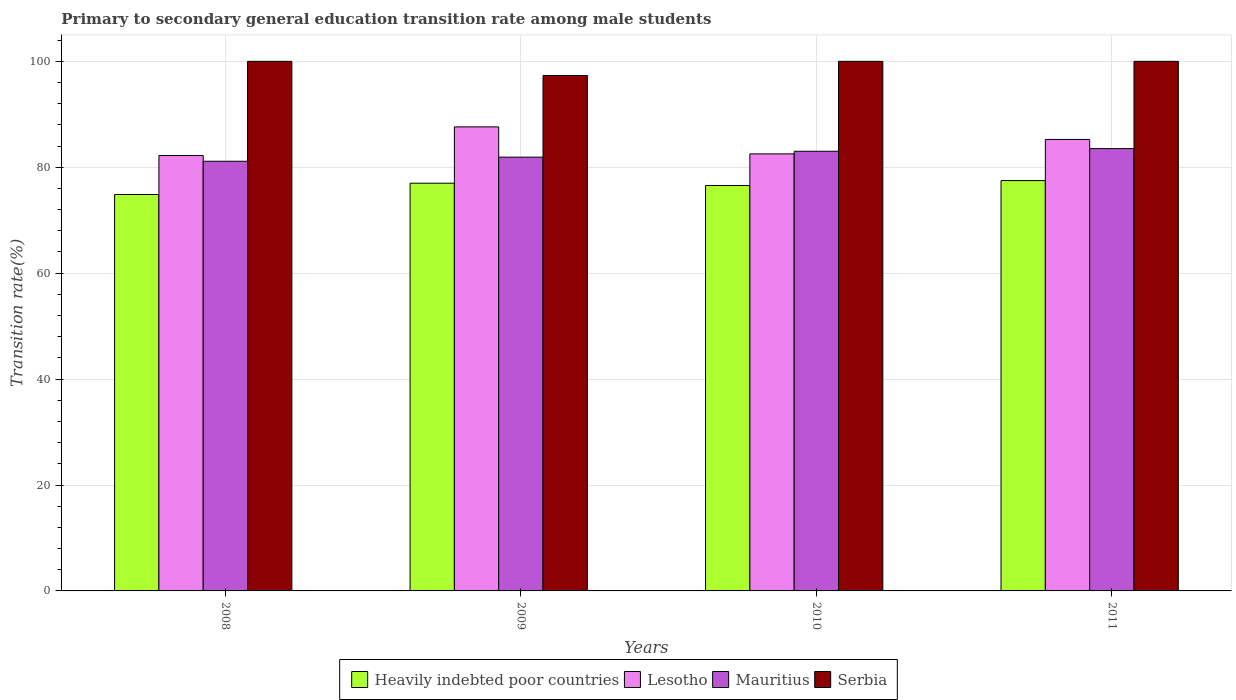How many groups of bars are there?
Offer a very short reply. 4. Are the number of bars per tick equal to the number of legend labels?
Make the answer very short. Yes. Are the number of bars on each tick of the X-axis equal?
Offer a very short reply. Yes. How many bars are there on the 1st tick from the left?
Your answer should be very brief. 4. How many bars are there on the 1st tick from the right?
Provide a short and direct response. 4. What is the label of the 4th group of bars from the left?
Your answer should be very brief. 2011. What is the transition rate in Heavily indebted poor countries in 2010?
Offer a very short reply. 76.56. Across all years, what is the minimum transition rate in Heavily indebted poor countries?
Provide a succinct answer. 74.86. In which year was the transition rate in Mauritius maximum?
Make the answer very short. 2011. In which year was the transition rate in Lesotho minimum?
Offer a terse response. 2008. What is the total transition rate in Serbia in the graph?
Provide a succinct answer. 397.33. What is the difference between the transition rate in Serbia in 2009 and that in 2011?
Offer a terse response. -2.67. What is the difference between the transition rate in Serbia in 2011 and the transition rate in Mauritius in 2010?
Provide a short and direct response. 16.98. What is the average transition rate in Heavily indebted poor countries per year?
Provide a succinct answer. 76.47. In the year 2010, what is the difference between the transition rate in Heavily indebted poor countries and transition rate in Lesotho?
Give a very brief answer. -5.97. What is the ratio of the transition rate in Heavily indebted poor countries in 2009 to that in 2011?
Make the answer very short. 0.99. What is the difference between the highest and the second highest transition rate in Heavily indebted poor countries?
Give a very brief answer. 0.49. What is the difference between the highest and the lowest transition rate in Serbia?
Make the answer very short. 2.67. In how many years, is the transition rate in Mauritius greater than the average transition rate in Mauritius taken over all years?
Your response must be concise. 2. Is the sum of the transition rate in Serbia in 2009 and 2011 greater than the maximum transition rate in Heavily indebted poor countries across all years?
Provide a short and direct response. Yes. What does the 2nd bar from the left in 2010 represents?
Your answer should be very brief. Lesotho. What does the 1st bar from the right in 2010 represents?
Give a very brief answer. Serbia. Is it the case that in every year, the sum of the transition rate in Lesotho and transition rate in Serbia is greater than the transition rate in Heavily indebted poor countries?
Make the answer very short. Yes. Are all the bars in the graph horizontal?
Provide a succinct answer. No. How many years are there in the graph?
Provide a short and direct response. 4. What is the difference between two consecutive major ticks on the Y-axis?
Your response must be concise. 20. Are the values on the major ticks of Y-axis written in scientific E-notation?
Keep it short and to the point. No. Where does the legend appear in the graph?
Give a very brief answer. Bottom center. How are the legend labels stacked?
Give a very brief answer. Horizontal. What is the title of the graph?
Your answer should be compact. Primary to secondary general education transition rate among male students. What is the label or title of the Y-axis?
Keep it short and to the point. Transition rate(%). What is the Transition rate(%) in Heavily indebted poor countries in 2008?
Your answer should be very brief. 74.86. What is the Transition rate(%) in Lesotho in 2008?
Your answer should be very brief. 82.22. What is the Transition rate(%) in Mauritius in 2008?
Provide a short and direct response. 81.13. What is the Transition rate(%) of Serbia in 2008?
Give a very brief answer. 100. What is the Transition rate(%) of Heavily indebted poor countries in 2009?
Ensure brevity in your answer.  76.99. What is the Transition rate(%) in Lesotho in 2009?
Your answer should be very brief. 87.62. What is the Transition rate(%) of Mauritius in 2009?
Your response must be concise. 81.91. What is the Transition rate(%) in Serbia in 2009?
Your answer should be very brief. 97.33. What is the Transition rate(%) of Heavily indebted poor countries in 2010?
Provide a succinct answer. 76.56. What is the Transition rate(%) in Lesotho in 2010?
Offer a very short reply. 82.53. What is the Transition rate(%) of Mauritius in 2010?
Offer a very short reply. 83.02. What is the Transition rate(%) of Heavily indebted poor countries in 2011?
Provide a short and direct response. 77.48. What is the Transition rate(%) of Lesotho in 2011?
Offer a very short reply. 85.25. What is the Transition rate(%) of Mauritius in 2011?
Your answer should be very brief. 83.52. Across all years, what is the maximum Transition rate(%) in Heavily indebted poor countries?
Your answer should be compact. 77.48. Across all years, what is the maximum Transition rate(%) of Lesotho?
Provide a short and direct response. 87.62. Across all years, what is the maximum Transition rate(%) of Mauritius?
Provide a short and direct response. 83.52. Across all years, what is the minimum Transition rate(%) of Heavily indebted poor countries?
Provide a succinct answer. 74.86. Across all years, what is the minimum Transition rate(%) in Lesotho?
Offer a terse response. 82.22. Across all years, what is the minimum Transition rate(%) in Mauritius?
Ensure brevity in your answer.  81.13. Across all years, what is the minimum Transition rate(%) of Serbia?
Your answer should be very brief. 97.33. What is the total Transition rate(%) of Heavily indebted poor countries in the graph?
Offer a terse response. 305.89. What is the total Transition rate(%) of Lesotho in the graph?
Offer a very short reply. 337.62. What is the total Transition rate(%) in Mauritius in the graph?
Provide a short and direct response. 329.59. What is the total Transition rate(%) in Serbia in the graph?
Offer a very short reply. 397.33. What is the difference between the Transition rate(%) in Heavily indebted poor countries in 2008 and that in 2009?
Ensure brevity in your answer.  -2.13. What is the difference between the Transition rate(%) in Lesotho in 2008 and that in 2009?
Provide a succinct answer. -5.41. What is the difference between the Transition rate(%) in Mauritius in 2008 and that in 2009?
Provide a short and direct response. -0.78. What is the difference between the Transition rate(%) in Serbia in 2008 and that in 2009?
Your answer should be very brief. 2.67. What is the difference between the Transition rate(%) in Heavily indebted poor countries in 2008 and that in 2010?
Offer a terse response. -1.7. What is the difference between the Transition rate(%) in Lesotho in 2008 and that in 2010?
Give a very brief answer. -0.31. What is the difference between the Transition rate(%) in Mauritius in 2008 and that in 2010?
Give a very brief answer. -1.88. What is the difference between the Transition rate(%) of Serbia in 2008 and that in 2010?
Provide a succinct answer. 0. What is the difference between the Transition rate(%) in Heavily indebted poor countries in 2008 and that in 2011?
Give a very brief answer. -2.63. What is the difference between the Transition rate(%) of Lesotho in 2008 and that in 2011?
Your answer should be compact. -3.04. What is the difference between the Transition rate(%) of Mauritius in 2008 and that in 2011?
Offer a terse response. -2.39. What is the difference between the Transition rate(%) of Heavily indebted poor countries in 2009 and that in 2010?
Your response must be concise. 0.43. What is the difference between the Transition rate(%) of Lesotho in 2009 and that in 2010?
Your answer should be very brief. 5.1. What is the difference between the Transition rate(%) of Mauritius in 2009 and that in 2010?
Ensure brevity in your answer.  -1.11. What is the difference between the Transition rate(%) of Serbia in 2009 and that in 2010?
Ensure brevity in your answer.  -2.67. What is the difference between the Transition rate(%) in Heavily indebted poor countries in 2009 and that in 2011?
Keep it short and to the point. -0.49. What is the difference between the Transition rate(%) of Lesotho in 2009 and that in 2011?
Your response must be concise. 2.37. What is the difference between the Transition rate(%) in Mauritius in 2009 and that in 2011?
Offer a very short reply. -1.61. What is the difference between the Transition rate(%) in Serbia in 2009 and that in 2011?
Provide a short and direct response. -2.67. What is the difference between the Transition rate(%) in Heavily indebted poor countries in 2010 and that in 2011?
Provide a succinct answer. -0.93. What is the difference between the Transition rate(%) in Lesotho in 2010 and that in 2011?
Provide a succinct answer. -2.73. What is the difference between the Transition rate(%) in Mauritius in 2010 and that in 2011?
Give a very brief answer. -0.51. What is the difference between the Transition rate(%) of Serbia in 2010 and that in 2011?
Provide a short and direct response. 0. What is the difference between the Transition rate(%) in Heavily indebted poor countries in 2008 and the Transition rate(%) in Lesotho in 2009?
Give a very brief answer. -12.77. What is the difference between the Transition rate(%) in Heavily indebted poor countries in 2008 and the Transition rate(%) in Mauritius in 2009?
Offer a very short reply. -7.05. What is the difference between the Transition rate(%) of Heavily indebted poor countries in 2008 and the Transition rate(%) of Serbia in 2009?
Your response must be concise. -22.48. What is the difference between the Transition rate(%) of Lesotho in 2008 and the Transition rate(%) of Mauritius in 2009?
Keep it short and to the point. 0.31. What is the difference between the Transition rate(%) of Lesotho in 2008 and the Transition rate(%) of Serbia in 2009?
Make the answer very short. -15.12. What is the difference between the Transition rate(%) in Mauritius in 2008 and the Transition rate(%) in Serbia in 2009?
Provide a short and direct response. -16.2. What is the difference between the Transition rate(%) of Heavily indebted poor countries in 2008 and the Transition rate(%) of Lesotho in 2010?
Offer a terse response. -7.67. What is the difference between the Transition rate(%) of Heavily indebted poor countries in 2008 and the Transition rate(%) of Mauritius in 2010?
Provide a short and direct response. -8.16. What is the difference between the Transition rate(%) of Heavily indebted poor countries in 2008 and the Transition rate(%) of Serbia in 2010?
Provide a succinct answer. -25.14. What is the difference between the Transition rate(%) of Lesotho in 2008 and the Transition rate(%) of Mauritius in 2010?
Provide a short and direct response. -0.8. What is the difference between the Transition rate(%) in Lesotho in 2008 and the Transition rate(%) in Serbia in 2010?
Keep it short and to the point. -17.78. What is the difference between the Transition rate(%) of Mauritius in 2008 and the Transition rate(%) of Serbia in 2010?
Offer a terse response. -18.87. What is the difference between the Transition rate(%) in Heavily indebted poor countries in 2008 and the Transition rate(%) in Lesotho in 2011?
Provide a short and direct response. -10.4. What is the difference between the Transition rate(%) of Heavily indebted poor countries in 2008 and the Transition rate(%) of Mauritius in 2011?
Your answer should be compact. -8.67. What is the difference between the Transition rate(%) in Heavily indebted poor countries in 2008 and the Transition rate(%) in Serbia in 2011?
Ensure brevity in your answer.  -25.14. What is the difference between the Transition rate(%) of Lesotho in 2008 and the Transition rate(%) of Mauritius in 2011?
Offer a terse response. -1.31. What is the difference between the Transition rate(%) in Lesotho in 2008 and the Transition rate(%) in Serbia in 2011?
Give a very brief answer. -17.78. What is the difference between the Transition rate(%) in Mauritius in 2008 and the Transition rate(%) in Serbia in 2011?
Your answer should be compact. -18.87. What is the difference between the Transition rate(%) of Heavily indebted poor countries in 2009 and the Transition rate(%) of Lesotho in 2010?
Ensure brevity in your answer.  -5.54. What is the difference between the Transition rate(%) of Heavily indebted poor countries in 2009 and the Transition rate(%) of Mauritius in 2010?
Provide a short and direct response. -6.03. What is the difference between the Transition rate(%) in Heavily indebted poor countries in 2009 and the Transition rate(%) in Serbia in 2010?
Offer a very short reply. -23.01. What is the difference between the Transition rate(%) of Lesotho in 2009 and the Transition rate(%) of Mauritius in 2010?
Provide a short and direct response. 4.6. What is the difference between the Transition rate(%) of Lesotho in 2009 and the Transition rate(%) of Serbia in 2010?
Offer a very short reply. -12.38. What is the difference between the Transition rate(%) in Mauritius in 2009 and the Transition rate(%) in Serbia in 2010?
Offer a terse response. -18.09. What is the difference between the Transition rate(%) of Heavily indebted poor countries in 2009 and the Transition rate(%) of Lesotho in 2011?
Make the answer very short. -8.26. What is the difference between the Transition rate(%) in Heavily indebted poor countries in 2009 and the Transition rate(%) in Mauritius in 2011?
Your response must be concise. -6.53. What is the difference between the Transition rate(%) of Heavily indebted poor countries in 2009 and the Transition rate(%) of Serbia in 2011?
Keep it short and to the point. -23.01. What is the difference between the Transition rate(%) of Lesotho in 2009 and the Transition rate(%) of Mauritius in 2011?
Keep it short and to the point. 4.1. What is the difference between the Transition rate(%) of Lesotho in 2009 and the Transition rate(%) of Serbia in 2011?
Provide a succinct answer. -12.38. What is the difference between the Transition rate(%) in Mauritius in 2009 and the Transition rate(%) in Serbia in 2011?
Ensure brevity in your answer.  -18.09. What is the difference between the Transition rate(%) in Heavily indebted poor countries in 2010 and the Transition rate(%) in Lesotho in 2011?
Keep it short and to the point. -8.69. What is the difference between the Transition rate(%) of Heavily indebted poor countries in 2010 and the Transition rate(%) of Mauritius in 2011?
Provide a short and direct response. -6.97. What is the difference between the Transition rate(%) in Heavily indebted poor countries in 2010 and the Transition rate(%) in Serbia in 2011?
Your answer should be very brief. -23.44. What is the difference between the Transition rate(%) of Lesotho in 2010 and the Transition rate(%) of Mauritius in 2011?
Your response must be concise. -1. What is the difference between the Transition rate(%) of Lesotho in 2010 and the Transition rate(%) of Serbia in 2011?
Your response must be concise. -17.47. What is the difference between the Transition rate(%) of Mauritius in 2010 and the Transition rate(%) of Serbia in 2011?
Ensure brevity in your answer.  -16.98. What is the average Transition rate(%) of Heavily indebted poor countries per year?
Provide a succinct answer. 76.47. What is the average Transition rate(%) of Lesotho per year?
Offer a terse response. 84.41. What is the average Transition rate(%) in Mauritius per year?
Provide a short and direct response. 82.4. What is the average Transition rate(%) in Serbia per year?
Provide a short and direct response. 99.33. In the year 2008, what is the difference between the Transition rate(%) of Heavily indebted poor countries and Transition rate(%) of Lesotho?
Offer a terse response. -7.36. In the year 2008, what is the difference between the Transition rate(%) in Heavily indebted poor countries and Transition rate(%) in Mauritius?
Your answer should be compact. -6.28. In the year 2008, what is the difference between the Transition rate(%) in Heavily indebted poor countries and Transition rate(%) in Serbia?
Your answer should be very brief. -25.14. In the year 2008, what is the difference between the Transition rate(%) in Lesotho and Transition rate(%) in Mauritius?
Provide a succinct answer. 1.08. In the year 2008, what is the difference between the Transition rate(%) of Lesotho and Transition rate(%) of Serbia?
Provide a succinct answer. -17.78. In the year 2008, what is the difference between the Transition rate(%) in Mauritius and Transition rate(%) in Serbia?
Make the answer very short. -18.87. In the year 2009, what is the difference between the Transition rate(%) in Heavily indebted poor countries and Transition rate(%) in Lesotho?
Keep it short and to the point. -10.63. In the year 2009, what is the difference between the Transition rate(%) in Heavily indebted poor countries and Transition rate(%) in Mauritius?
Make the answer very short. -4.92. In the year 2009, what is the difference between the Transition rate(%) of Heavily indebted poor countries and Transition rate(%) of Serbia?
Your answer should be very brief. -20.34. In the year 2009, what is the difference between the Transition rate(%) in Lesotho and Transition rate(%) in Mauritius?
Ensure brevity in your answer.  5.71. In the year 2009, what is the difference between the Transition rate(%) of Lesotho and Transition rate(%) of Serbia?
Your response must be concise. -9.71. In the year 2009, what is the difference between the Transition rate(%) of Mauritius and Transition rate(%) of Serbia?
Your answer should be compact. -15.42. In the year 2010, what is the difference between the Transition rate(%) of Heavily indebted poor countries and Transition rate(%) of Lesotho?
Keep it short and to the point. -5.97. In the year 2010, what is the difference between the Transition rate(%) in Heavily indebted poor countries and Transition rate(%) in Mauritius?
Your answer should be very brief. -6.46. In the year 2010, what is the difference between the Transition rate(%) of Heavily indebted poor countries and Transition rate(%) of Serbia?
Ensure brevity in your answer.  -23.44. In the year 2010, what is the difference between the Transition rate(%) of Lesotho and Transition rate(%) of Mauritius?
Keep it short and to the point. -0.49. In the year 2010, what is the difference between the Transition rate(%) of Lesotho and Transition rate(%) of Serbia?
Give a very brief answer. -17.47. In the year 2010, what is the difference between the Transition rate(%) of Mauritius and Transition rate(%) of Serbia?
Provide a short and direct response. -16.98. In the year 2011, what is the difference between the Transition rate(%) of Heavily indebted poor countries and Transition rate(%) of Lesotho?
Provide a succinct answer. -7.77. In the year 2011, what is the difference between the Transition rate(%) in Heavily indebted poor countries and Transition rate(%) in Mauritius?
Ensure brevity in your answer.  -6.04. In the year 2011, what is the difference between the Transition rate(%) in Heavily indebted poor countries and Transition rate(%) in Serbia?
Keep it short and to the point. -22.52. In the year 2011, what is the difference between the Transition rate(%) in Lesotho and Transition rate(%) in Mauritius?
Offer a terse response. 1.73. In the year 2011, what is the difference between the Transition rate(%) of Lesotho and Transition rate(%) of Serbia?
Offer a terse response. -14.75. In the year 2011, what is the difference between the Transition rate(%) in Mauritius and Transition rate(%) in Serbia?
Provide a short and direct response. -16.48. What is the ratio of the Transition rate(%) of Heavily indebted poor countries in 2008 to that in 2009?
Your response must be concise. 0.97. What is the ratio of the Transition rate(%) in Lesotho in 2008 to that in 2009?
Your answer should be very brief. 0.94. What is the ratio of the Transition rate(%) of Mauritius in 2008 to that in 2009?
Make the answer very short. 0.99. What is the ratio of the Transition rate(%) in Serbia in 2008 to that in 2009?
Your answer should be compact. 1.03. What is the ratio of the Transition rate(%) in Heavily indebted poor countries in 2008 to that in 2010?
Give a very brief answer. 0.98. What is the ratio of the Transition rate(%) of Lesotho in 2008 to that in 2010?
Provide a succinct answer. 1. What is the ratio of the Transition rate(%) in Mauritius in 2008 to that in 2010?
Offer a very short reply. 0.98. What is the ratio of the Transition rate(%) in Heavily indebted poor countries in 2008 to that in 2011?
Provide a succinct answer. 0.97. What is the ratio of the Transition rate(%) in Lesotho in 2008 to that in 2011?
Your response must be concise. 0.96. What is the ratio of the Transition rate(%) of Mauritius in 2008 to that in 2011?
Give a very brief answer. 0.97. What is the ratio of the Transition rate(%) in Heavily indebted poor countries in 2009 to that in 2010?
Provide a succinct answer. 1.01. What is the ratio of the Transition rate(%) in Lesotho in 2009 to that in 2010?
Offer a very short reply. 1.06. What is the ratio of the Transition rate(%) in Mauritius in 2009 to that in 2010?
Offer a terse response. 0.99. What is the ratio of the Transition rate(%) of Serbia in 2009 to that in 2010?
Your response must be concise. 0.97. What is the ratio of the Transition rate(%) of Heavily indebted poor countries in 2009 to that in 2011?
Offer a very short reply. 0.99. What is the ratio of the Transition rate(%) in Lesotho in 2009 to that in 2011?
Your response must be concise. 1.03. What is the ratio of the Transition rate(%) of Mauritius in 2009 to that in 2011?
Offer a terse response. 0.98. What is the ratio of the Transition rate(%) of Serbia in 2009 to that in 2011?
Provide a short and direct response. 0.97. What is the ratio of the Transition rate(%) of Heavily indebted poor countries in 2010 to that in 2011?
Offer a very short reply. 0.99. What is the ratio of the Transition rate(%) in Lesotho in 2010 to that in 2011?
Your response must be concise. 0.97. What is the ratio of the Transition rate(%) of Mauritius in 2010 to that in 2011?
Give a very brief answer. 0.99. What is the difference between the highest and the second highest Transition rate(%) of Heavily indebted poor countries?
Provide a succinct answer. 0.49. What is the difference between the highest and the second highest Transition rate(%) in Lesotho?
Offer a terse response. 2.37. What is the difference between the highest and the second highest Transition rate(%) in Mauritius?
Keep it short and to the point. 0.51. What is the difference between the highest and the lowest Transition rate(%) of Heavily indebted poor countries?
Keep it short and to the point. 2.63. What is the difference between the highest and the lowest Transition rate(%) in Lesotho?
Offer a very short reply. 5.41. What is the difference between the highest and the lowest Transition rate(%) in Mauritius?
Keep it short and to the point. 2.39. What is the difference between the highest and the lowest Transition rate(%) in Serbia?
Give a very brief answer. 2.67. 